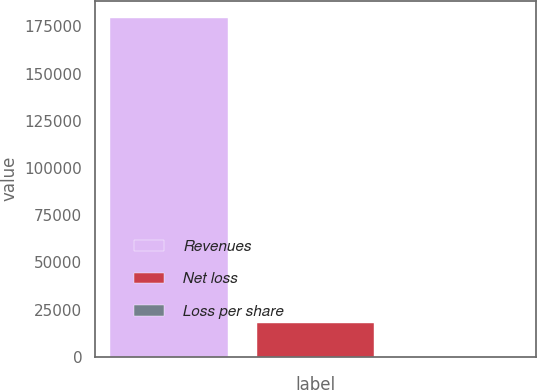Convert chart. <chart><loc_0><loc_0><loc_500><loc_500><bar_chart><fcel>Revenues<fcel>Net loss<fcel>Loss per share<nl><fcel>179581<fcel>17958.2<fcel>0.15<nl></chart> 